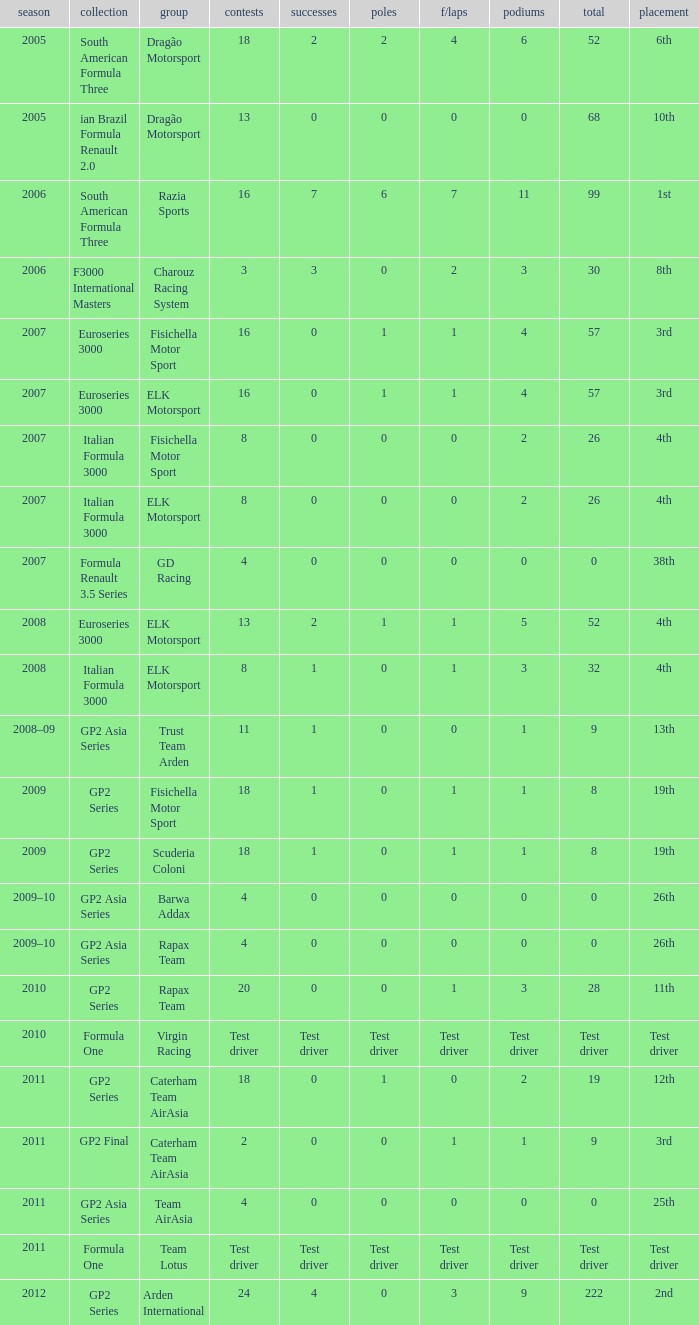What was the F/Laps when the Wins were 0 and the Position was 4th? 0, 0. 